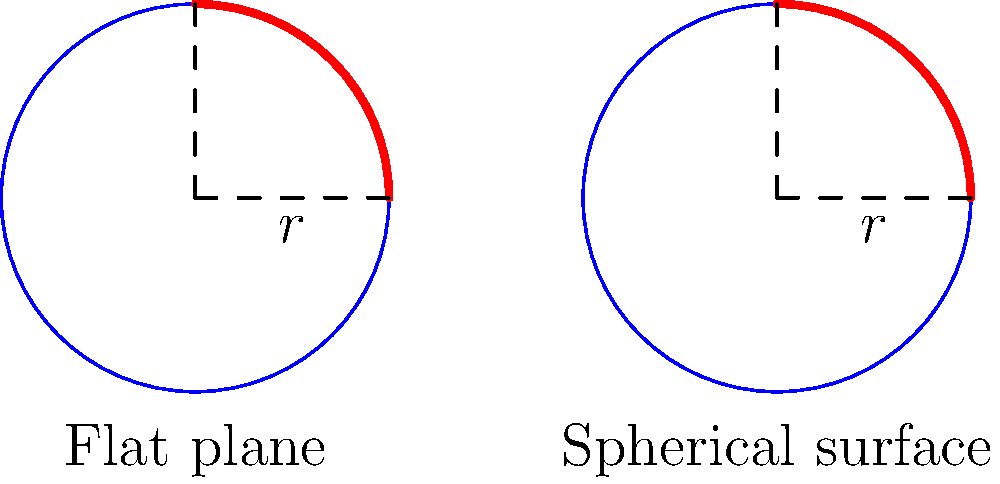Consider a circle with radius $r$ on a flat plane and the same circle on the surface of a sphere with radius $R$. How does the area of the circle on the spherical surface compare to the area on the flat plane when $r$ is much smaller than $R$? Let's approach this step-by-step:

1) Area of a circle on a flat plane:
   $$A_{flat} = \pi r^2$$

2) Area of a circle on a spherical surface:
   $$A_{sphere} = 2\pi R^2 (1 - \cos(\theta))$$
   where $\theta$ is the angle subtended at the center of the sphere.

3) The relationship between $r$, $R$, and $\theta$ (for small $r$):
   $$r \approx R\theta$$

4) Substituting this into the spherical area formula:
   $$A_{sphere} = 2\pi R^2 (1 - \cos(\frac{r}{R}))$$

5) Using the Taylor series expansion of cosine for small angles:
   $$\cos(x) \approx 1 - \frac{x^2}{2} + \frac{x^4}{24} - ...$$

6) Applying this to our formula:
   $$A_{sphere} \approx 2\pi R^2 (1 - (1 - \frac{r^2}{2R^2}))$$
   $$A_{sphere} \approx \pi r^2 (1 - \frac{r^2}{12R^2})$$

7) Comparing to the flat plane area:
   $$\frac{A_{sphere}}{A_{flat}} \approx 1 - \frac{r^2}{12R^2}$$

8) When $r$ is much smaller than $R$, the fraction $\frac{r^2}{12R^2}$ becomes very small.

Therefore, for small $r$ compared to $R$, the area of the circle on the spherical surface is slightly smaller than on the flat plane, but the difference is negligible.
Answer: Slightly smaller, but nearly equal for $r \ll R$ 